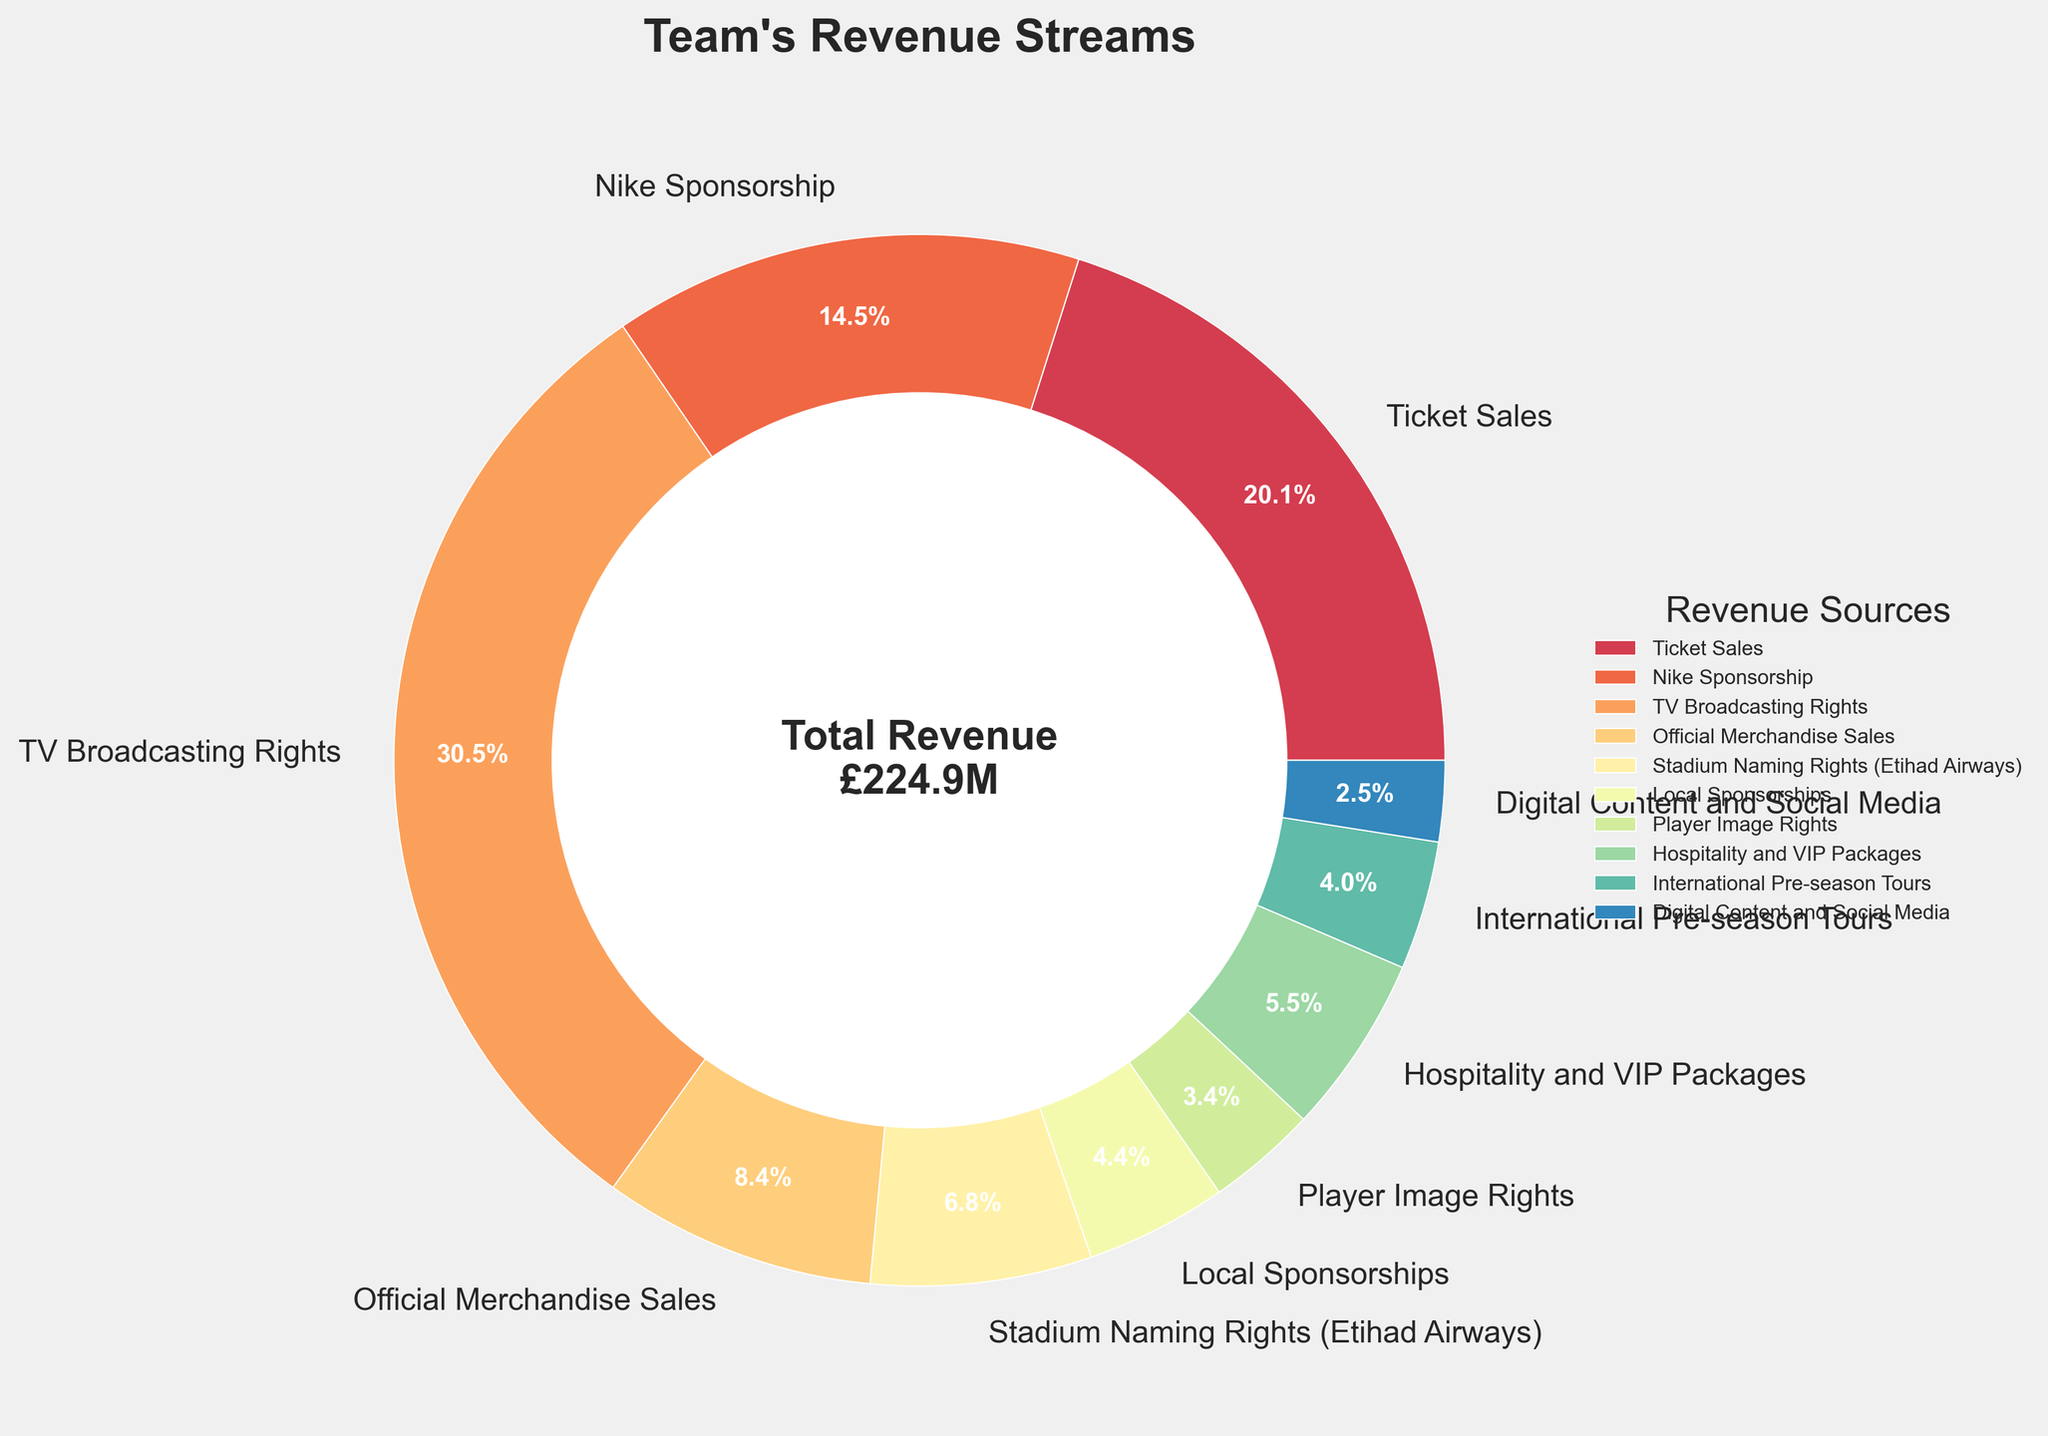What is the total revenue from TV Broadcasting Rights and Nike Sponsorship? Add the revenue from TV Broadcasting Rights (£68.7M) and Nike Sponsorship (£32.5M): 68.7 + 32.5 = 101.2
Answer: 101.2M Which category contributes the least to the team's revenue? Identify the category with the smallest slice of the pie chart, which is Digital Content and Social Media at £5.6M
Answer: Digital Content and Social Media How much more revenue does Ticket Sales generate compared to Hospitality and VIP Packages? Subtract the revenue from Hospitality and VIP Packages (£12.4M) from Ticket Sales (£45.2M): 45.2 - 12.4 = 32.8
Answer: 32.8M What percentage of the total revenue comes from TV Broadcasting Rights? TV Broadcasting Rights is £68.7M out of a total revenue of £224.9M. Calculate the percentage: (68.7 / 224.9) * 100 ≈ 30.5%
Answer: 30.5% Which revenue category is the second-largest contributor? Identify the second-largest slice of the pie chart after TV Broadcasting Rights, which is Ticket Sales at £45.2M
Answer: Ticket Sales How do the combined revenues from Local Sponsorships and Player Image Rights compare to Nike Sponsorship alone? Add the revenue from Local Sponsorships (£9.8M) and Player Image Rights (£7.6M): 9.8 + 7.6 = 17.4, which is less than Nike Sponsorship (£32.5M)
Answer: Less What is the total revenue from all sponsorship-related categories (Nike Sponsorship, Stadium Naming Rights, Local Sponsorships)? Add the revenues: Nike Sponsorship (£32.5M), Stadium Naming Rights (£15.3M), Local Sponsorships (£9.8M): 32.5 + 15.3 + 9.8 = 57.6
Answer: 57.6M Which revenue category's slice is visually closest in size to Ticket Sales? Identify the slice closest in size to Ticket Sales, which is TV Broadcasting Rights (£68.7M)
Answer: TV Broadcasting Rights Calculate the average revenue from International Pre-season Tours, Digital Content and Social Media, and Player Image Rights. Add the revenues: International Pre-season Tours (£8.9M), Digital Content and Social Media (£5.6M), Player Image Rights (£7.6M). Average is: (8.9 + 5.6 + 7.6) / 3 ≈ 7.37
Answer: 7.37M 